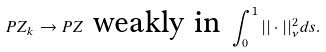<formula> <loc_0><loc_0><loc_500><loc_500>P Z _ { k } \rightarrow P Z \text { weakly in } \int _ { 0 } ^ { 1 } | | \cdot | | _ { \nu } ^ { 2 } d s .</formula> 